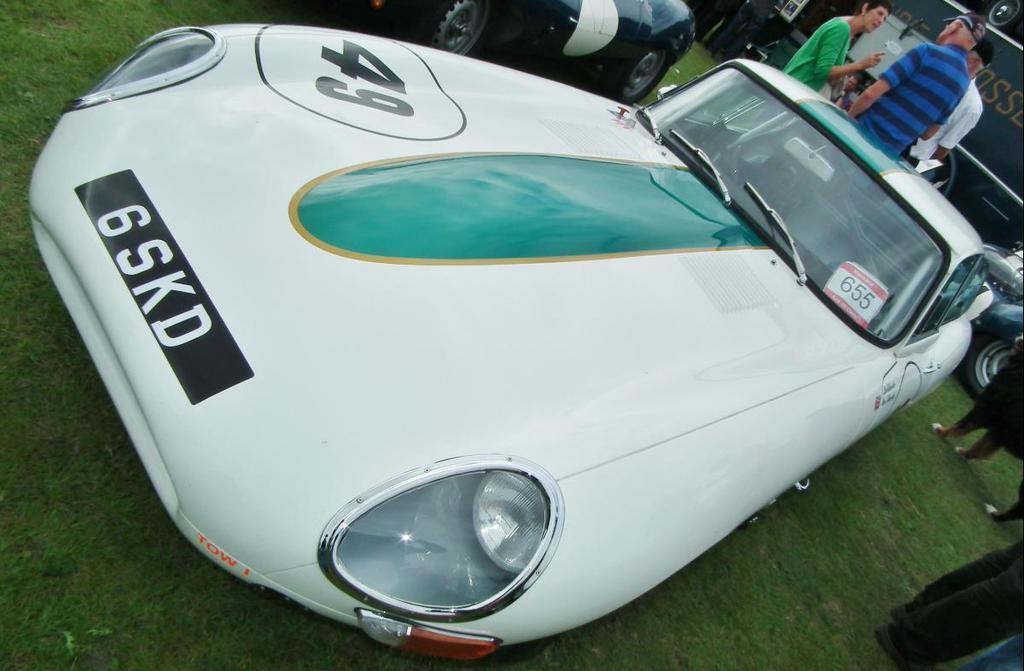Please provide a concise description of this image. As we can see in the image there are cars, group of people, building and grass. 